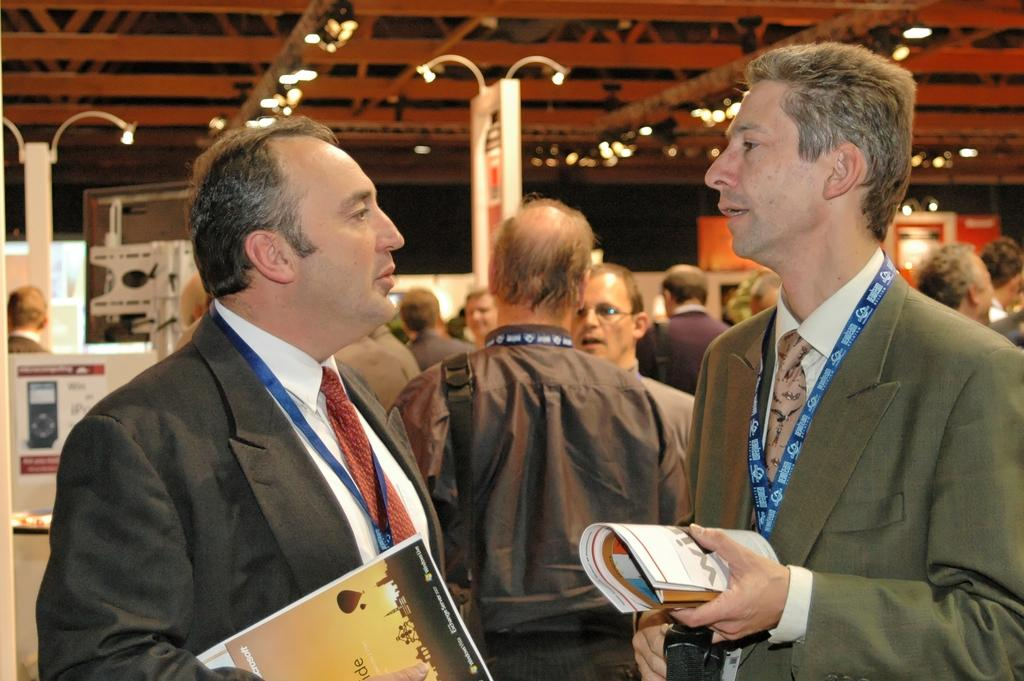How many persons are in the center of the image? There are two persons standing in the center of the image. What are the two persons holding in the image? The two persons are holding books. Can you describe the background of the image? There are many persons, lights, boards, and iron bars visible in the background. What type of cup can be seen hanging from the iron bars in the image? There is no cup present in the image, and it does not show any hanging from the iron bars. 